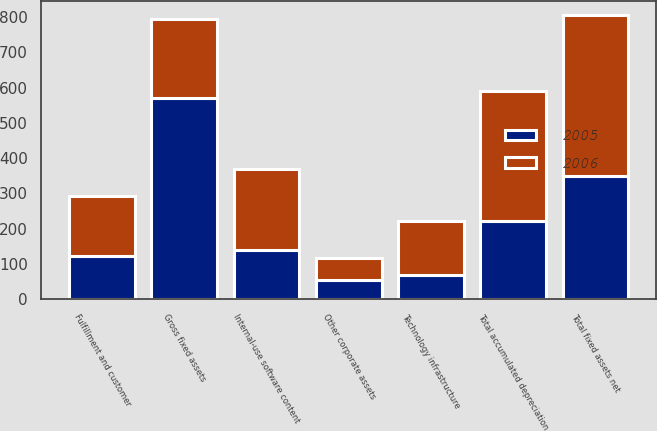Convert chart. <chart><loc_0><loc_0><loc_500><loc_500><stacked_bar_chart><ecel><fcel>Fulfillment and customer<fcel>Technology infrastructure<fcel>Internal-use software content<fcel>Other corporate assets<fcel>Gross fixed assets<fcel>Total accumulated depreciation<fcel>Total fixed assets net<nl><fcel>2006<fcel>171<fcel>153<fcel>230<fcel>62<fcel>223<fcel>367<fcel>457<nl><fcel>2005<fcel>123<fcel>69<fcel>138<fcel>55<fcel>571<fcel>223<fcel>348<nl></chart> 